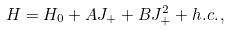<formula> <loc_0><loc_0><loc_500><loc_500>H = H _ { 0 } + A J _ { + } + B J _ { + } ^ { 2 } + h . c . \, ,</formula> 